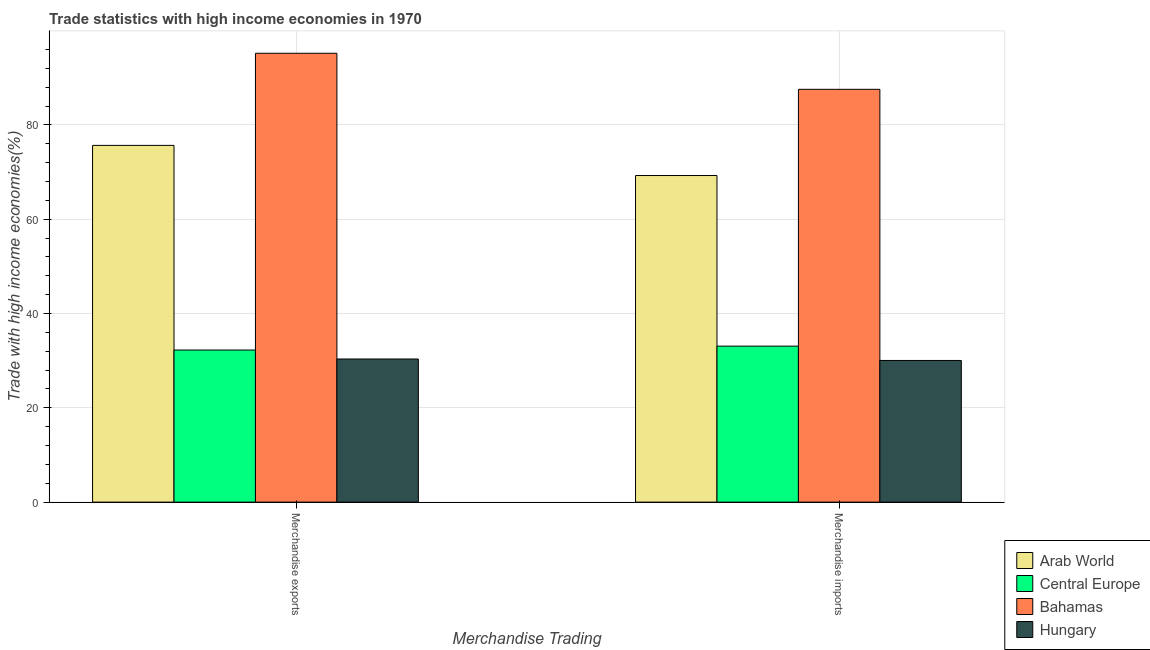How many groups of bars are there?
Your answer should be very brief. 2. How many bars are there on the 1st tick from the left?
Give a very brief answer. 4. How many bars are there on the 1st tick from the right?
Offer a terse response. 4. What is the merchandise imports in Arab World?
Keep it short and to the point. 69.28. Across all countries, what is the maximum merchandise imports?
Provide a short and direct response. 87.57. Across all countries, what is the minimum merchandise exports?
Offer a very short reply. 30.36. In which country was the merchandise exports maximum?
Provide a succinct answer. Bahamas. In which country was the merchandise imports minimum?
Make the answer very short. Hungary. What is the total merchandise exports in the graph?
Offer a terse response. 233.51. What is the difference between the merchandise imports in Arab World and that in Central Europe?
Provide a short and direct response. 36.19. What is the difference between the merchandise exports in Central Europe and the merchandise imports in Bahamas?
Provide a succinct answer. -55.3. What is the average merchandise imports per country?
Offer a very short reply. 55. What is the difference between the merchandise imports and merchandise exports in Hungary?
Offer a very short reply. -0.31. In how many countries, is the merchandise exports greater than 48 %?
Provide a short and direct response. 2. What is the ratio of the merchandise imports in Bahamas to that in Arab World?
Provide a succinct answer. 1.26. Is the merchandise imports in Central Europe less than that in Hungary?
Offer a very short reply. No. In how many countries, is the merchandise exports greater than the average merchandise exports taken over all countries?
Your response must be concise. 2. What does the 3rd bar from the left in Merchandise imports represents?
Provide a succinct answer. Bahamas. What does the 4th bar from the right in Merchandise exports represents?
Provide a succinct answer. Arab World. What is the difference between two consecutive major ticks on the Y-axis?
Offer a terse response. 20. Does the graph contain any zero values?
Keep it short and to the point. No. Where does the legend appear in the graph?
Offer a terse response. Bottom right. How are the legend labels stacked?
Your answer should be very brief. Vertical. What is the title of the graph?
Offer a terse response. Trade statistics with high income economies in 1970. What is the label or title of the X-axis?
Your answer should be very brief. Merchandise Trading. What is the label or title of the Y-axis?
Your answer should be very brief. Trade with high income economies(%). What is the Trade with high income economies(%) of Arab World in Merchandise exports?
Make the answer very short. 75.67. What is the Trade with high income economies(%) in Central Europe in Merchandise exports?
Offer a very short reply. 32.26. What is the Trade with high income economies(%) in Bahamas in Merchandise exports?
Your response must be concise. 95.21. What is the Trade with high income economies(%) of Hungary in Merchandise exports?
Your answer should be compact. 30.36. What is the Trade with high income economies(%) in Arab World in Merchandise imports?
Give a very brief answer. 69.28. What is the Trade with high income economies(%) of Central Europe in Merchandise imports?
Make the answer very short. 33.09. What is the Trade with high income economies(%) in Bahamas in Merchandise imports?
Your response must be concise. 87.57. What is the Trade with high income economies(%) in Hungary in Merchandise imports?
Your answer should be very brief. 30.05. Across all Merchandise Trading, what is the maximum Trade with high income economies(%) of Arab World?
Your answer should be compact. 75.67. Across all Merchandise Trading, what is the maximum Trade with high income economies(%) in Central Europe?
Give a very brief answer. 33.09. Across all Merchandise Trading, what is the maximum Trade with high income economies(%) in Bahamas?
Ensure brevity in your answer.  95.21. Across all Merchandise Trading, what is the maximum Trade with high income economies(%) in Hungary?
Keep it short and to the point. 30.36. Across all Merchandise Trading, what is the minimum Trade with high income economies(%) of Arab World?
Your response must be concise. 69.28. Across all Merchandise Trading, what is the minimum Trade with high income economies(%) of Central Europe?
Your answer should be compact. 32.26. Across all Merchandise Trading, what is the minimum Trade with high income economies(%) of Bahamas?
Offer a terse response. 87.57. Across all Merchandise Trading, what is the minimum Trade with high income economies(%) in Hungary?
Ensure brevity in your answer.  30.05. What is the total Trade with high income economies(%) of Arab World in the graph?
Your answer should be compact. 144.95. What is the total Trade with high income economies(%) of Central Europe in the graph?
Your answer should be very brief. 65.35. What is the total Trade with high income economies(%) of Bahamas in the graph?
Provide a succinct answer. 182.78. What is the total Trade with high income economies(%) of Hungary in the graph?
Provide a short and direct response. 60.41. What is the difference between the Trade with high income economies(%) of Arab World in Merchandise exports and that in Merchandise imports?
Give a very brief answer. 6.39. What is the difference between the Trade with high income economies(%) of Central Europe in Merchandise exports and that in Merchandise imports?
Make the answer very short. -0.83. What is the difference between the Trade with high income economies(%) of Bahamas in Merchandise exports and that in Merchandise imports?
Provide a succinct answer. 7.65. What is the difference between the Trade with high income economies(%) in Hungary in Merchandise exports and that in Merchandise imports?
Offer a terse response. 0.31. What is the difference between the Trade with high income economies(%) of Arab World in Merchandise exports and the Trade with high income economies(%) of Central Europe in Merchandise imports?
Give a very brief answer. 42.59. What is the difference between the Trade with high income economies(%) in Arab World in Merchandise exports and the Trade with high income economies(%) in Bahamas in Merchandise imports?
Ensure brevity in your answer.  -11.89. What is the difference between the Trade with high income economies(%) in Arab World in Merchandise exports and the Trade with high income economies(%) in Hungary in Merchandise imports?
Offer a very short reply. 45.62. What is the difference between the Trade with high income economies(%) in Central Europe in Merchandise exports and the Trade with high income economies(%) in Bahamas in Merchandise imports?
Offer a very short reply. -55.3. What is the difference between the Trade with high income economies(%) in Central Europe in Merchandise exports and the Trade with high income economies(%) in Hungary in Merchandise imports?
Offer a terse response. 2.21. What is the difference between the Trade with high income economies(%) of Bahamas in Merchandise exports and the Trade with high income economies(%) of Hungary in Merchandise imports?
Offer a very short reply. 65.16. What is the average Trade with high income economies(%) of Arab World per Merchandise Trading?
Your answer should be very brief. 72.48. What is the average Trade with high income economies(%) of Central Europe per Merchandise Trading?
Offer a terse response. 32.68. What is the average Trade with high income economies(%) of Bahamas per Merchandise Trading?
Give a very brief answer. 91.39. What is the average Trade with high income economies(%) of Hungary per Merchandise Trading?
Your answer should be very brief. 30.21. What is the difference between the Trade with high income economies(%) in Arab World and Trade with high income economies(%) in Central Europe in Merchandise exports?
Provide a short and direct response. 43.41. What is the difference between the Trade with high income economies(%) of Arab World and Trade with high income economies(%) of Bahamas in Merchandise exports?
Ensure brevity in your answer.  -19.54. What is the difference between the Trade with high income economies(%) of Arab World and Trade with high income economies(%) of Hungary in Merchandise exports?
Provide a succinct answer. 45.31. What is the difference between the Trade with high income economies(%) of Central Europe and Trade with high income economies(%) of Bahamas in Merchandise exports?
Give a very brief answer. -62.95. What is the difference between the Trade with high income economies(%) of Central Europe and Trade with high income economies(%) of Hungary in Merchandise exports?
Keep it short and to the point. 1.9. What is the difference between the Trade with high income economies(%) in Bahamas and Trade with high income economies(%) in Hungary in Merchandise exports?
Make the answer very short. 64.85. What is the difference between the Trade with high income economies(%) in Arab World and Trade with high income economies(%) in Central Europe in Merchandise imports?
Your answer should be very brief. 36.19. What is the difference between the Trade with high income economies(%) in Arab World and Trade with high income economies(%) in Bahamas in Merchandise imports?
Your response must be concise. -18.29. What is the difference between the Trade with high income economies(%) in Arab World and Trade with high income economies(%) in Hungary in Merchandise imports?
Provide a short and direct response. 39.23. What is the difference between the Trade with high income economies(%) of Central Europe and Trade with high income economies(%) of Bahamas in Merchandise imports?
Your answer should be compact. -54.48. What is the difference between the Trade with high income economies(%) of Central Europe and Trade with high income economies(%) of Hungary in Merchandise imports?
Provide a short and direct response. 3.04. What is the difference between the Trade with high income economies(%) of Bahamas and Trade with high income economies(%) of Hungary in Merchandise imports?
Offer a terse response. 57.51. What is the ratio of the Trade with high income economies(%) of Arab World in Merchandise exports to that in Merchandise imports?
Provide a succinct answer. 1.09. What is the ratio of the Trade with high income economies(%) of Bahamas in Merchandise exports to that in Merchandise imports?
Give a very brief answer. 1.09. What is the ratio of the Trade with high income economies(%) in Hungary in Merchandise exports to that in Merchandise imports?
Offer a very short reply. 1.01. What is the difference between the highest and the second highest Trade with high income economies(%) in Arab World?
Offer a very short reply. 6.39. What is the difference between the highest and the second highest Trade with high income economies(%) in Central Europe?
Provide a short and direct response. 0.83. What is the difference between the highest and the second highest Trade with high income economies(%) in Bahamas?
Offer a very short reply. 7.65. What is the difference between the highest and the second highest Trade with high income economies(%) in Hungary?
Make the answer very short. 0.31. What is the difference between the highest and the lowest Trade with high income economies(%) of Arab World?
Give a very brief answer. 6.39. What is the difference between the highest and the lowest Trade with high income economies(%) of Central Europe?
Your answer should be compact. 0.83. What is the difference between the highest and the lowest Trade with high income economies(%) in Bahamas?
Offer a terse response. 7.65. What is the difference between the highest and the lowest Trade with high income economies(%) of Hungary?
Offer a terse response. 0.31. 